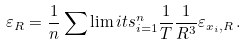Convert formula to latex. <formula><loc_0><loc_0><loc_500><loc_500>\varepsilon _ { R } = \frac { 1 } { n } \sum \lim i t s _ { i = 1 } ^ { n } \frac { 1 } { T } \frac { 1 } { R ^ { 3 } } \varepsilon _ { x _ { i } , R } \, .</formula> 